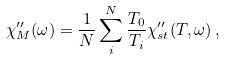<formula> <loc_0><loc_0><loc_500><loc_500>\chi _ { M } ^ { \prime \prime } ( \omega ) = \frac { 1 } { N } \sum _ { i } ^ { N } \frac { T _ { 0 } } { T _ { i } } \chi _ { s t } ^ { \prime \prime } ( T , \omega ) \, ,</formula> 